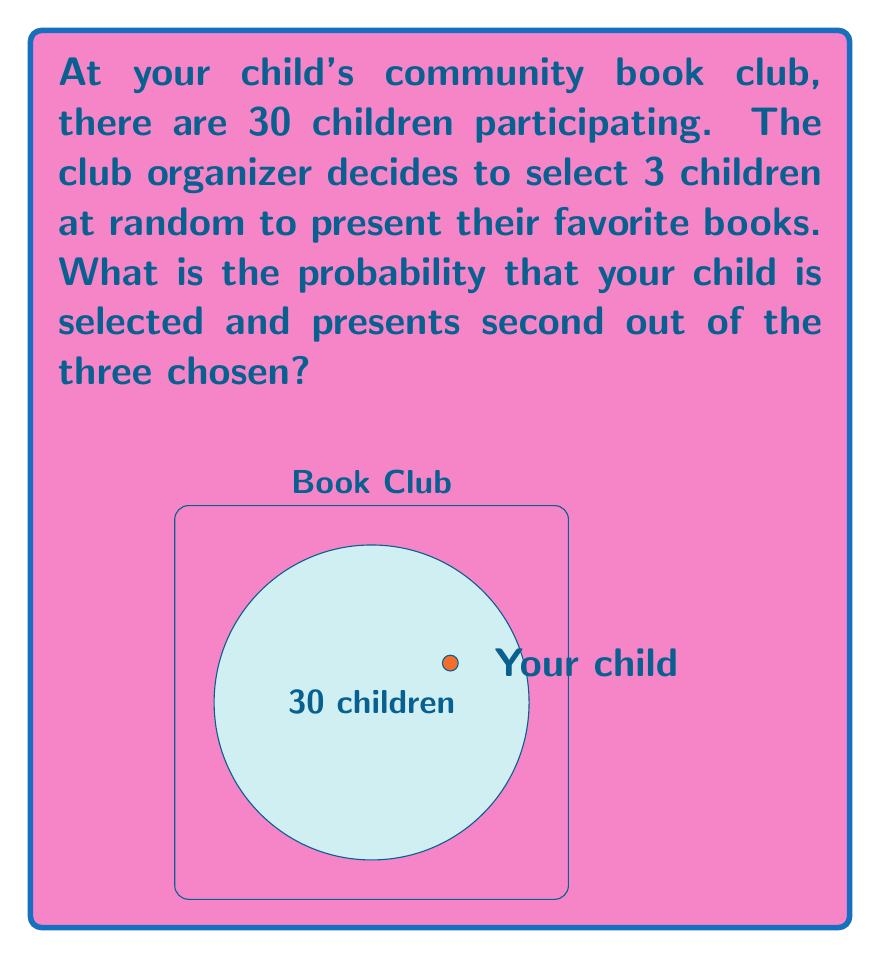What is the answer to this math problem? Let's approach this step-by-step:

1) First, we need to calculate the probability of your child being selected as one of the three presenters.
   - There are $\binom{30}{3}$ ways to select 3 children out of 30.
   - There are $\binom{29}{2}$ ways to select the other 2 children if your child is included.
   - So, the probability of your child being selected is:

   $$P(\text{child selected}) = \frac{\binom{29}{2}}{\binom{30}{3}}$$

2) Now, given that your child is selected, we need to calculate the probability of them presenting second.
   - If your child is selected, they have an equal chance of presenting first, second, or third.
   - So, the probability of presenting second, given that they are selected, is $\frac{1}{3}$.

3) The overall probability is the product of these two probabilities:

   $$P(\text{child selected and presents second}) = P(\text{child selected}) \times P(\text{presents second | selected})$$

   $$= \frac{\binom{29}{2}}{\binom{30}{3}} \times \frac{1}{3}$$

4) Let's calculate this:
   $$\binom{30}{3} = \frac{30!}{3!(30-3)!} = \frac{30 \times 29 \times 28}{3 \times 2 \times 1} = 4060$$
   $$\binom{29}{2} = \frac{29!}{2!(29-2)!} = \frac{29 \times 28}{2 \times 1} = 406$$

   So, the final probability is:

   $$\frac{406}{4060} \times \frac{1}{3} = \frac{1}{30}$$
Answer: $\frac{1}{30}$ 